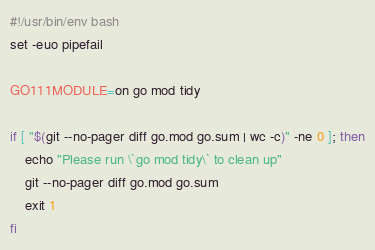Convert code to text. <code><loc_0><loc_0><loc_500><loc_500><_Bash_>#!/usr/bin/env bash
set -euo pipefail

GO111MODULE=on go mod tidy

if [ "$(git --no-pager diff go.mod go.sum | wc -c)" -ne 0 ]; then
	echo "Please run \`go mod tidy\` to clean up"
	git --no-pager diff go.mod go.sum
	exit 1
fi
</code> 